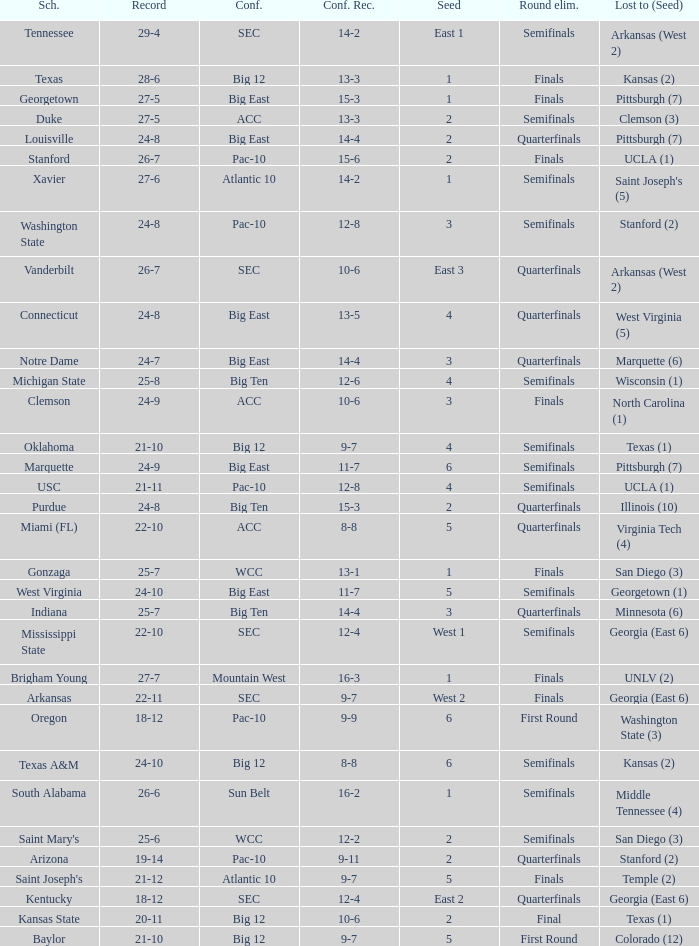Identify the educational institution having a 12-6 conference record. Michigan State. 